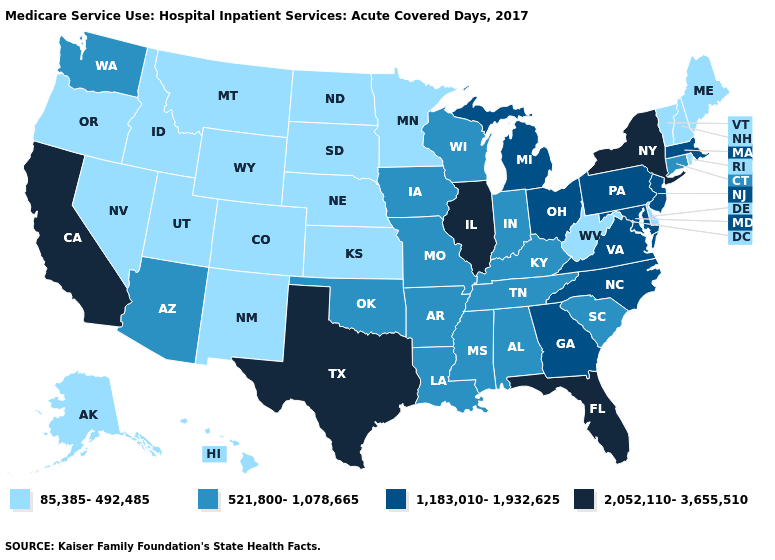Does the first symbol in the legend represent the smallest category?
Quick response, please. Yes. Among the states that border Wisconsin , which have the lowest value?
Keep it brief. Minnesota. Name the states that have a value in the range 85,385-492,485?
Concise answer only. Alaska, Colorado, Delaware, Hawaii, Idaho, Kansas, Maine, Minnesota, Montana, Nebraska, Nevada, New Hampshire, New Mexico, North Dakota, Oregon, Rhode Island, South Dakota, Utah, Vermont, West Virginia, Wyoming. Name the states that have a value in the range 2,052,110-3,655,510?
Keep it brief. California, Florida, Illinois, New York, Texas. What is the lowest value in the USA?
Write a very short answer. 85,385-492,485. Name the states that have a value in the range 2,052,110-3,655,510?
Quick response, please. California, Florida, Illinois, New York, Texas. What is the value of Nevada?
Keep it brief. 85,385-492,485. Name the states that have a value in the range 85,385-492,485?
Concise answer only. Alaska, Colorado, Delaware, Hawaii, Idaho, Kansas, Maine, Minnesota, Montana, Nebraska, Nevada, New Hampshire, New Mexico, North Dakota, Oregon, Rhode Island, South Dakota, Utah, Vermont, West Virginia, Wyoming. Which states have the lowest value in the USA?
Short answer required. Alaska, Colorado, Delaware, Hawaii, Idaho, Kansas, Maine, Minnesota, Montana, Nebraska, Nevada, New Hampshire, New Mexico, North Dakota, Oregon, Rhode Island, South Dakota, Utah, Vermont, West Virginia, Wyoming. Does Illinois have the highest value in the MidWest?
Write a very short answer. Yes. Among the states that border New Jersey , does New York have the highest value?
Keep it brief. Yes. Name the states that have a value in the range 85,385-492,485?
Answer briefly. Alaska, Colorado, Delaware, Hawaii, Idaho, Kansas, Maine, Minnesota, Montana, Nebraska, Nevada, New Hampshire, New Mexico, North Dakota, Oregon, Rhode Island, South Dakota, Utah, Vermont, West Virginia, Wyoming. Does California have the highest value in the West?
Be succinct. Yes. Does Texas have the highest value in the USA?
Answer briefly. Yes. What is the value of Alaska?
Write a very short answer. 85,385-492,485. 